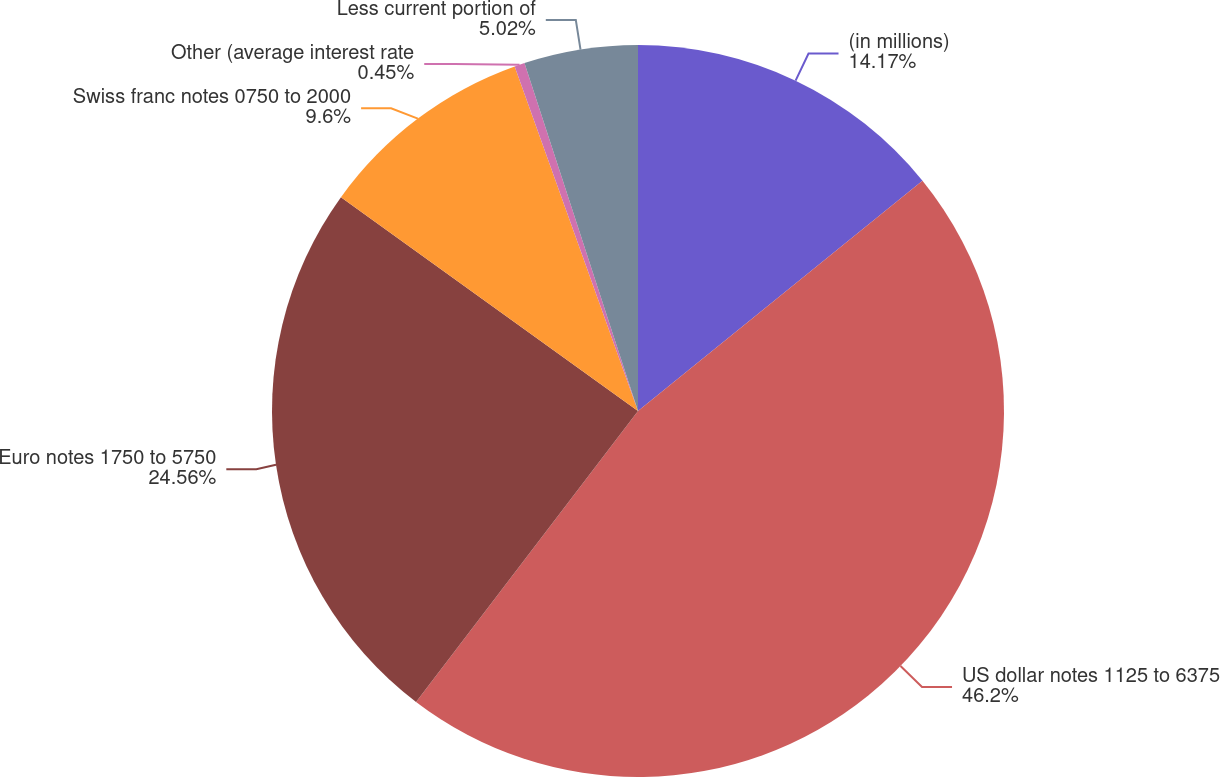Convert chart to OTSL. <chart><loc_0><loc_0><loc_500><loc_500><pie_chart><fcel>(in millions)<fcel>US dollar notes 1125 to 6375<fcel>Euro notes 1750 to 5750<fcel>Swiss franc notes 0750 to 2000<fcel>Other (average interest rate<fcel>Less current portion of<nl><fcel>14.17%<fcel>46.2%<fcel>24.56%<fcel>9.6%<fcel>0.45%<fcel>5.02%<nl></chart> 